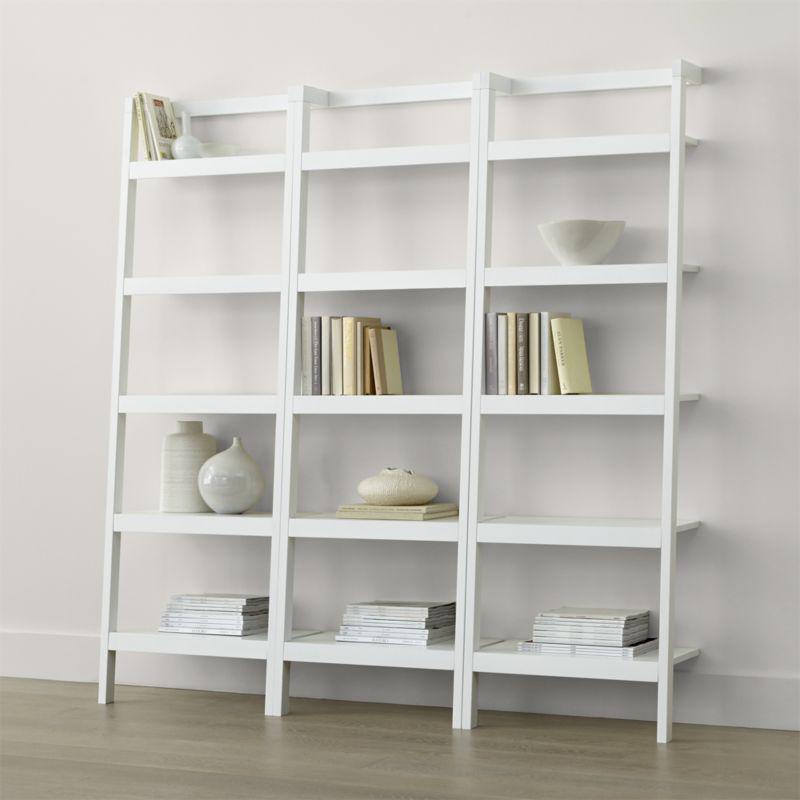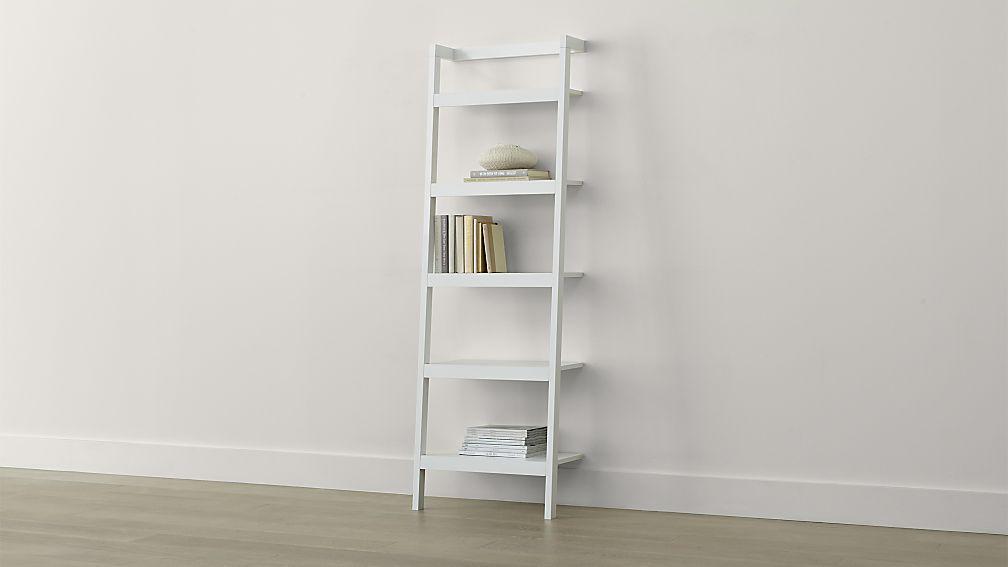The first image is the image on the left, the second image is the image on the right. Analyze the images presented: Is the assertion "One image shows a single set of white shelves supported by a white wall." valid? Answer yes or no. Yes. 